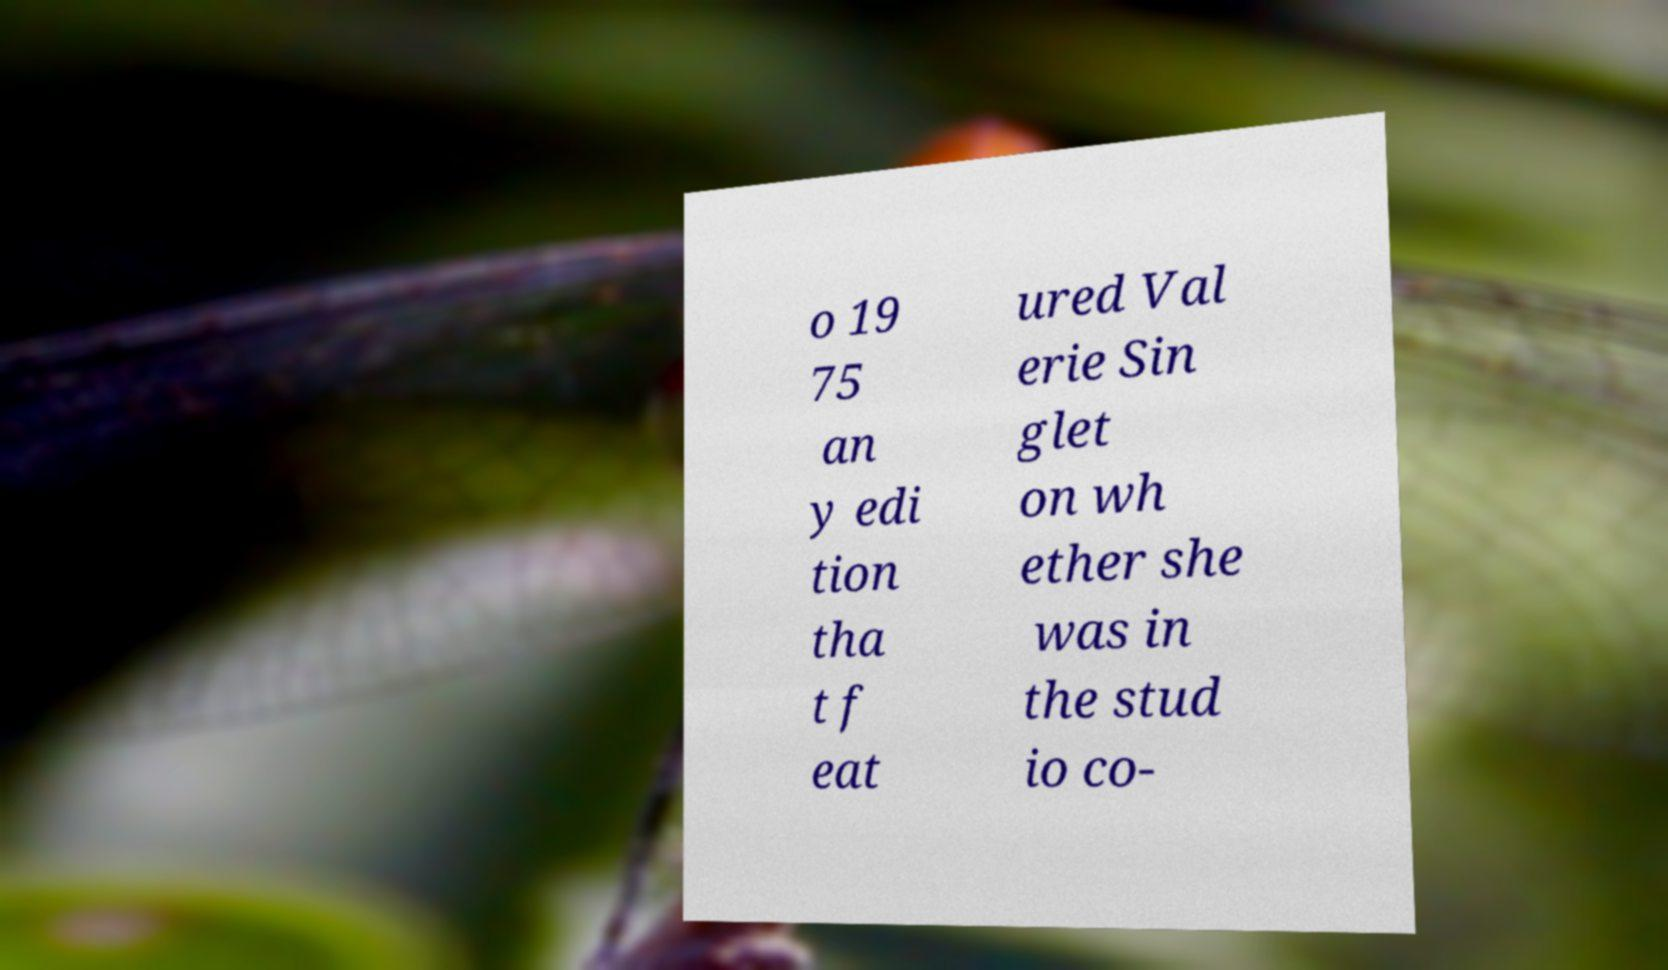Please read and relay the text visible in this image. What does it say? o 19 75 an y edi tion tha t f eat ured Val erie Sin glet on wh ether she was in the stud io co- 